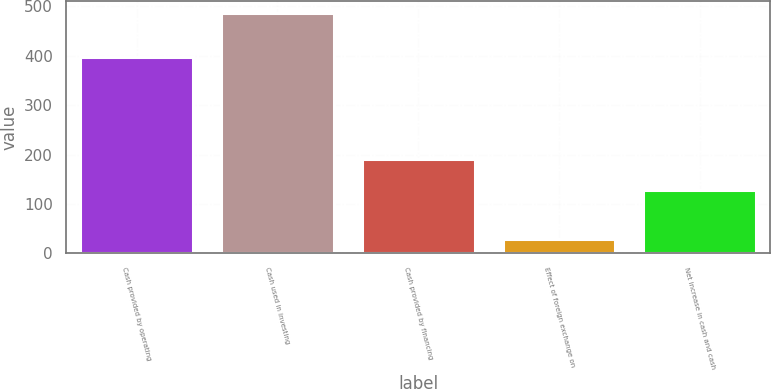<chart> <loc_0><loc_0><loc_500><loc_500><bar_chart><fcel>Cash provided by operating<fcel>Cash used in investing<fcel>Cash provided by financing<fcel>Effect of foreign exchange on<fcel>Net increase in cash and cash<nl><fcel>397<fcel>487<fcel>190<fcel>29<fcel>129<nl></chart> 